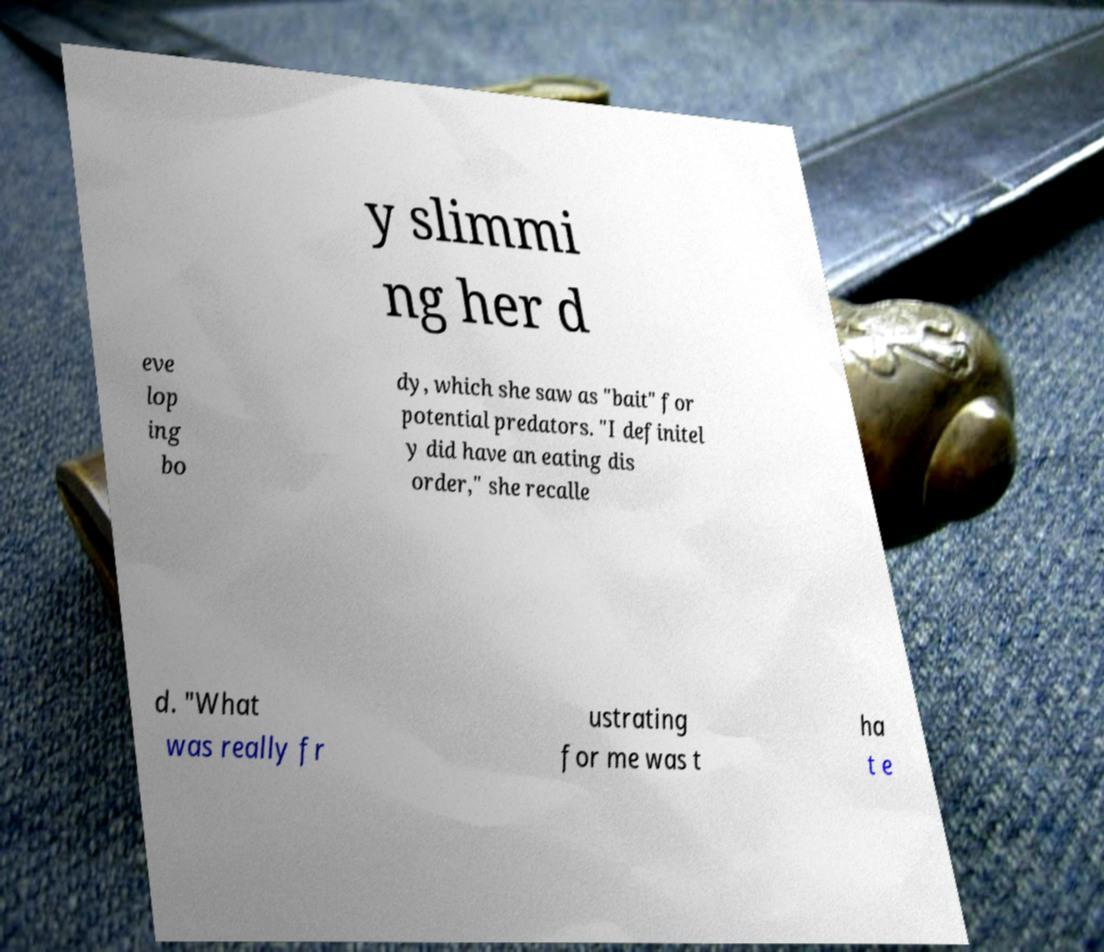Can you read and provide the text displayed in the image?This photo seems to have some interesting text. Can you extract and type it out for me? y slimmi ng her d eve lop ing bo dy, which she saw as "bait" for potential predators. "I definitel y did have an eating dis order," she recalle d. "What was really fr ustrating for me was t ha t e 